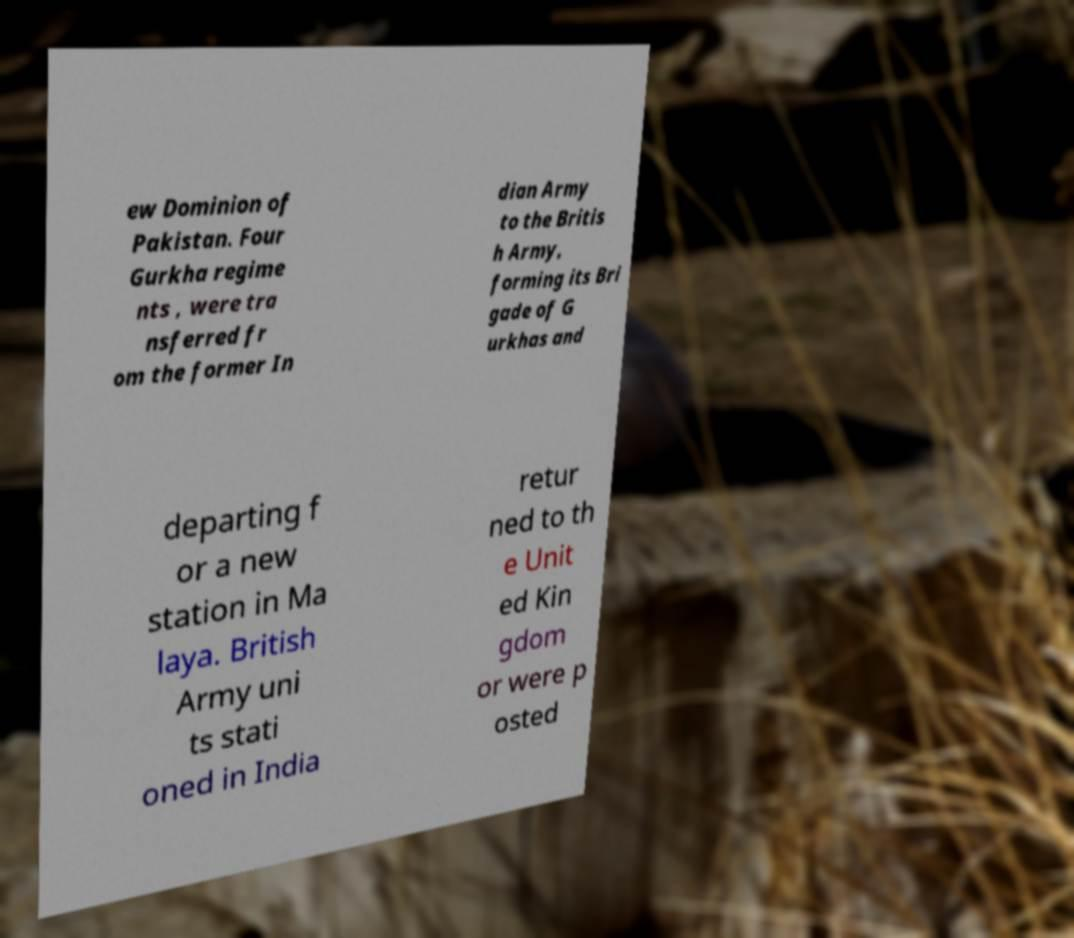Can you read and provide the text displayed in the image?This photo seems to have some interesting text. Can you extract and type it out for me? ew Dominion of Pakistan. Four Gurkha regime nts , were tra nsferred fr om the former In dian Army to the Britis h Army, forming its Bri gade of G urkhas and departing f or a new station in Ma laya. British Army uni ts stati oned in India retur ned to th e Unit ed Kin gdom or were p osted 